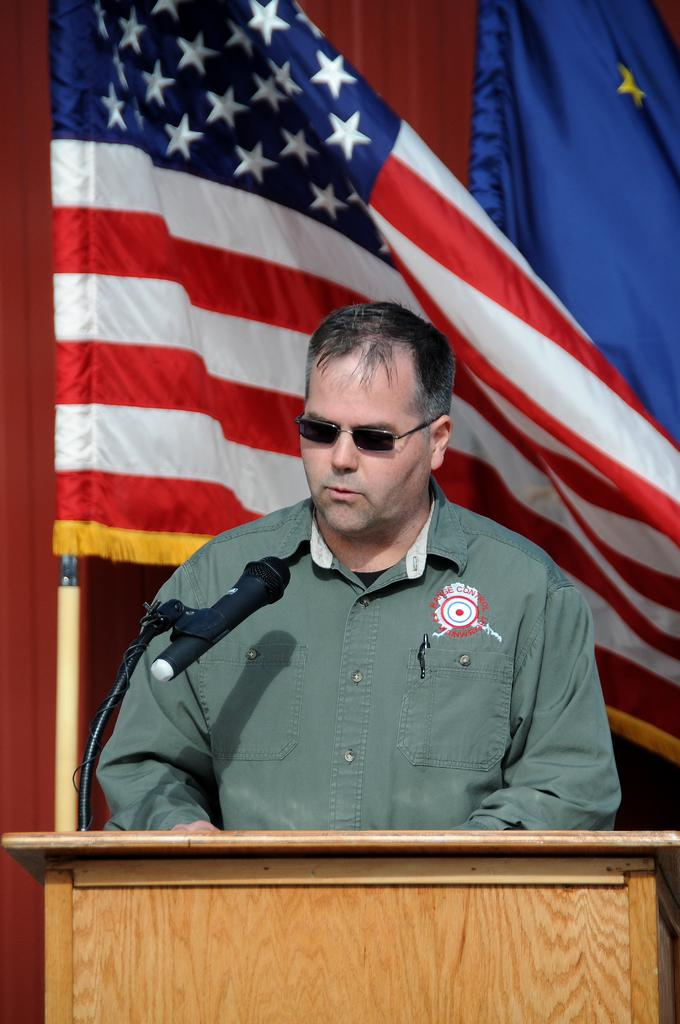Who is the main subject in the image? There is a man in the center of the image. What is in front of the man? There is a desk and a microphone in front of the man. What can be seen in the background of the image? There are flags in the background of the image. What type of polish is the man applying to his nails in the image? There is no indication in the image that the man is applying polish to his nails, as he is focused on the desk and microphone in front of him. 